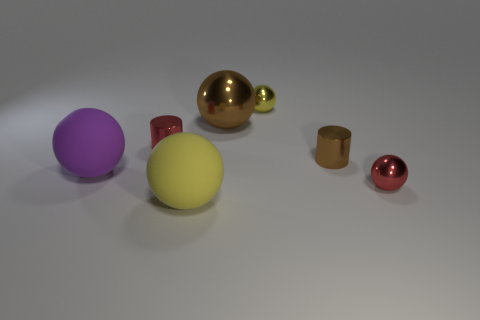Subtract all yellow shiny balls. How many balls are left? 4 Add 2 large blue things. How many objects exist? 9 Subtract all yellow spheres. How many spheres are left? 3 Subtract all purple cylinders. How many yellow balls are left? 2 Subtract all balls. How many objects are left? 2 Subtract all large cyan shiny objects. Subtract all tiny red metallic things. How many objects are left? 5 Add 5 red cylinders. How many red cylinders are left? 6 Add 4 small metal spheres. How many small metal spheres exist? 6 Subtract 0 cyan balls. How many objects are left? 7 Subtract 3 spheres. How many spheres are left? 2 